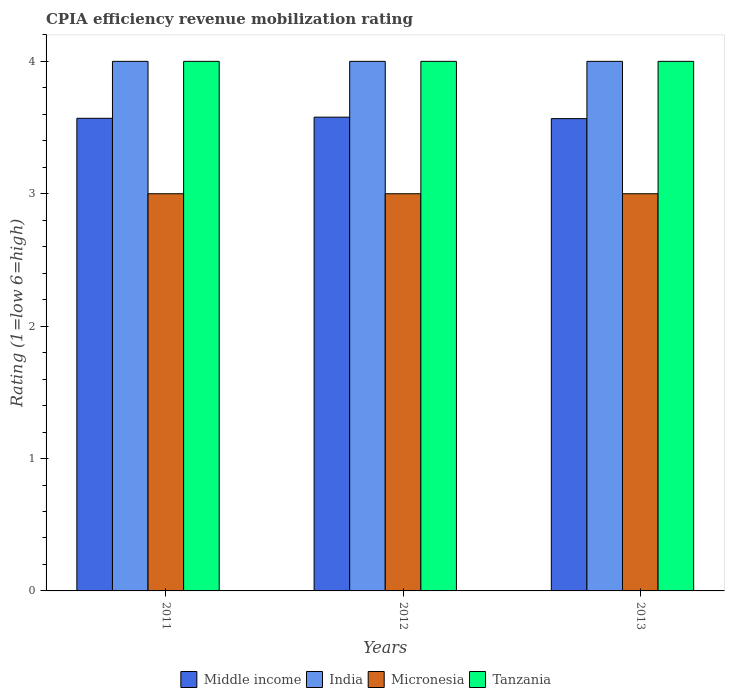How many different coloured bars are there?
Provide a succinct answer. 4. How many groups of bars are there?
Your response must be concise. 3. Are the number of bars per tick equal to the number of legend labels?
Your response must be concise. Yes. How many bars are there on the 2nd tick from the right?
Provide a succinct answer. 4. In how many cases, is the number of bars for a given year not equal to the number of legend labels?
Offer a terse response. 0. What is the CPIA rating in Tanzania in 2013?
Provide a short and direct response. 4. Across all years, what is the maximum CPIA rating in Middle income?
Your response must be concise. 3.58. Across all years, what is the minimum CPIA rating in Middle income?
Ensure brevity in your answer.  3.57. What is the total CPIA rating in Tanzania in the graph?
Offer a terse response. 12. What is the difference between the CPIA rating in Middle income in 2012 and that in 2013?
Offer a terse response. 0.01. What is the difference between the CPIA rating in Middle income in 2011 and the CPIA rating in Tanzania in 2013?
Your answer should be compact. -0.43. In the year 2013, what is the difference between the CPIA rating in Micronesia and CPIA rating in Middle income?
Your response must be concise. -0.57. In how many years, is the CPIA rating in Tanzania greater than 3.6?
Ensure brevity in your answer.  3. Is the CPIA rating in Micronesia in 2011 less than that in 2013?
Keep it short and to the point. No. Is the difference between the CPIA rating in Micronesia in 2012 and 2013 greater than the difference between the CPIA rating in Middle income in 2012 and 2013?
Keep it short and to the point. No. What is the difference between the highest and the second highest CPIA rating in Middle income?
Keep it short and to the point. 0.01. What is the difference between the highest and the lowest CPIA rating in Middle income?
Provide a short and direct response. 0.01. What does the 1st bar from the left in 2012 represents?
Make the answer very short. Middle income. Are all the bars in the graph horizontal?
Keep it short and to the point. No. What is the difference between two consecutive major ticks on the Y-axis?
Offer a very short reply. 1. Are the values on the major ticks of Y-axis written in scientific E-notation?
Offer a terse response. No. What is the title of the graph?
Provide a short and direct response. CPIA efficiency revenue mobilization rating. What is the label or title of the Y-axis?
Provide a short and direct response. Rating (1=low 6=high). What is the Rating (1=low 6=high) in Middle income in 2011?
Your response must be concise. 3.57. What is the Rating (1=low 6=high) of India in 2011?
Give a very brief answer. 4. What is the Rating (1=low 6=high) in Micronesia in 2011?
Give a very brief answer. 3. What is the Rating (1=low 6=high) in Tanzania in 2011?
Your response must be concise. 4. What is the Rating (1=low 6=high) in Middle income in 2012?
Make the answer very short. 3.58. What is the Rating (1=low 6=high) of India in 2012?
Your answer should be very brief. 4. What is the Rating (1=low 6=high) of Middle income in 2013?
Provide a short and direct response. 3.57. What is the Rating (1=low 6=high) in Tanzania in 2013?
Keep it short and to the point. 4. Across all years, what is the maximum Rating (1=low 6=high) in Middle income?
Provide a succinct answer. 3.58. Across all years, what is the maximum Rating (1=low 6=high) of Tanzania?
Ensure brevity in your answer.  4. Across all years, what is the minimum Rating (1=low 6=high) in Middle income?
Your response must be concise. 3.57. What is the total Rating (1=low 6=high) of Middle income in the graph?
Your answer should be very brief. 10.72. What is the total Rating (1=low 6=high) in India in the graph?
Your response must be concise. 12. What is the difference between the Rating (1=low 6=high) in Middle income in 2011 and that in 2012?
Offer a terse response. -0.01. What is the difference between the Rating (1=low 6=high) of India in 2011 and that in 2012?
Your answer should be very brief. 0. What is the difference between the Rating (1=low 6=high) in Middle income in 2011 and that in 2013?
Your answer should be compact. 0. What is the difference between the Rating (1=low 6=high) of Tanzania in 2011 and that in 2013?
Your response must be concise. 0. What is the difference between the Rating (1=low 6=high) of Middle income in 2012 and that in 2013?
Your answer should be very brief. 0.01. What is the difference between the Rating (1=low 6=high) of Tanzania in 2012 and that in 2013?
Your answer should be compact. 0. What is the difference between the Rating (1=low 6=high) in Middle income in 2011 and the Rating (1=low 6=high) in India in 2012?
Your response must be concise. -0.43. What is the difference between the Rating (1=low 6=high) of Middle income in 2011 and the Rating (1=low 6=high) of Micronesia in 2012?
Your answer should be compact. 0.57. What is the difference between the Rating (1=low 6=high) in Middle income in 2011 and the Rating (1=low 6=high) in Tanzania in 2012?
Offer a very short reply. -0.43. What is the difference between the Rating (1=low 6=high) in India in 2011 and the Rating (1=low 6=high) in Micronesia in 2012?
Ensure brevity in your answer.  1. What is the difference between the Rating (1=low 6=high) of Middle income in 2011 and the Rating (1=low 6=high) of India in 2013?
Ensure brevity in your answer.  -0.43. What is the difference between the Rating (1=low 6=high) in Middle income in 2011 and the Rating (1=low 6=high) in Micronesia in 2013?
Provide a short and direct response. 0.57. What is the difference between the Rating (1=low 6=high) of Middle income in 2011 and the Rating (1=low 6=high) of Tanzania in 2013?
Give a very brief answer. -0.43. What is the difference between the Rating (1=low 6=high) in India in 2011 and the Rating (1=low 6=high) in Micronesia in 2013?
Offer a very short reply. 1. What is the difference between the Rating (1=low 6=high) of India in 2011 and the Rating (1=low 6=high) of Tanzania in 2013?
Your answer should be compact. 0. What is the difference between the Rating (1=low 6=high) in Micronesia in 2011 and the Rating (1=low 6=high) in Tanzania in 2013?
Make the answer very short. -1. What is the difference between the Rating (1=low 6=high) in Middle income in 2012 and the Rating (1=low 6=high) in India in 2013?
Your response must be concise. -0.42. What is the difference between the Rating (1=low 6=high) in Middle income in 2012 and the Rating (1=low 6=high) in Micronesia in 2013?
Your response must be concise. 0.58. What is the difference between the Rating (1=low 6=high) in Middle income in 2012 and the Rating (1=low 6=high) in Tanzania in 2013?
Provide a short and direct response. -0.42. What is the difference between the Rating (1=low 6=high) of Micronesia in 2012 and the Rating (1=low 6=high) of Tanzania in 2013?
Give a very brief answer. -1. What is the average Rating (1=low 6=high) in Middle income per year?
Your answer should be very brief. 3.57. What is the average Rating (1=low 6=high) of India per year?
Ensure brevity in your answer.  4. What is the average Rating (1=low 6=high) of Micronesia per year?
Give a very brief answer. 3. What is the average Rating (1=low 6=high) of Tanzania per year?
Provide a succinct answer. 4. In the year 2011, what is the difference between the Rating (1=low 6=high) in Middle income and Rating (1=low 6=high) in India?
Ensure brevity in your answer.  -0.43. In the year 2011, what is the difference between the Rating (1=low 6=high) of Middle income and Rating (1=low 6=high) of Micronesia?
Offer a terse response. 0.57. In the year 2011, what is the difference between the Rating (1=low 6=high) in Middle income and Rating (1=low 6=high) in Tanzania?
Provide a succinct answer. -0.43. In the year 2011, what is the difference between the Rating (1=low 6=high) in Micronesia and Rating (1=low 6=high) in Tanzania?
Make the answer very short. -1. In the year 2012, what is the difference between the Rating (1=low 6=high) of Middle income and Rating (1=low 6=high) of India?
Make the answer very short. -0.42. In the year 2012, what is the difference between the Rating (1=low 6=high) in Middle income and Rating (1=low 6=high) in Micronesia?
Offer a very short reply. 0.58. In the year 2012, what is the difference between the Rating (1=low 6=high) in Middle income and Rating (1=low 6=high) in Tanzania?
Your answer should be very brief. -0.42. In the year 2012, what is the difference between the Rating (1=low 6=high) of India and Rating (1=low 6=high) of Micronesia?
Provide a short and direct response. 1. In the year 2012, what is the difference between the Rating (1=low 6=high) of India and Rating (1=low 6=high) of Tanzania?
Give a very brief answer. 0. In the year 2012, what is the difference between the Rating (1=low 6=high) in Micronesia and Rating (1=low 6=high) in Tanzania?
Keep it short and to the point. -1. In the year 2013, what is the difference between the Rating (1=low 6=high) of Middle income and Rating (1=low 6=high) of India?
Your response must be concise. -0.43. In the year 2013, what is the difference between the Rating (1=low 6=high) in Middle income and Rating (1=low 6=high) in Micronesia?
Your answer should be very brief. 0.57. In the year 2013, what is the difference between the Rating (1=low 6=high) of Middle income and Rating (1=low 6=high) of Tanzania?
Your answer should be compact. -0.43. In the year 2013, what is the difference between the Rating (1=low 6=high) in India and Rating (1=low 6=high) in Micronesia?
Provide a succinct answer. 1. What is the ratio of the Rating (1=low 6=high) of Middle income in 2011 to that in 2012?
Your response must be concise. 1. What is the ratio of the Rating (1=low 6=high) in India in 2011 to that in 2012?
Your response must be concise. 1. What is the ratio of the Rating (1=low 6=high) in Tanzania in 2011 to that in 2012?
Ensure brevity in your answer.  1. What is the ratio of the Rating (1=low 6=high) of India in 2011 to that in 2013?
Offer a very short reply. 1. What is the ratio of the Rating (1=low 6=high) in Micronesia in 2011 to that in 2013?
Offer a very short reply. 1. What is the ratio of the Rating (1=low 6=high) of India in 2012 to that in 2013?
Ensure brevity in your answer.  1. What is the difference between the highest and the second highest Rating (1=low 6=high) of Middle income?
Your answer should be compact. 0.01. What is the difference between the highest and the second highest Rating (1=low 6=high) in Micronesia?
Make the answer very short. 0. What is the difference between the highest and the lowest Rating (1=low 6=high) in Middle income?
Your answer should be compact. 0.01. What is the difference between the highest and the lowest Rating (1=low 6=high) of India?
Ensure brevity in your answer.  0. 